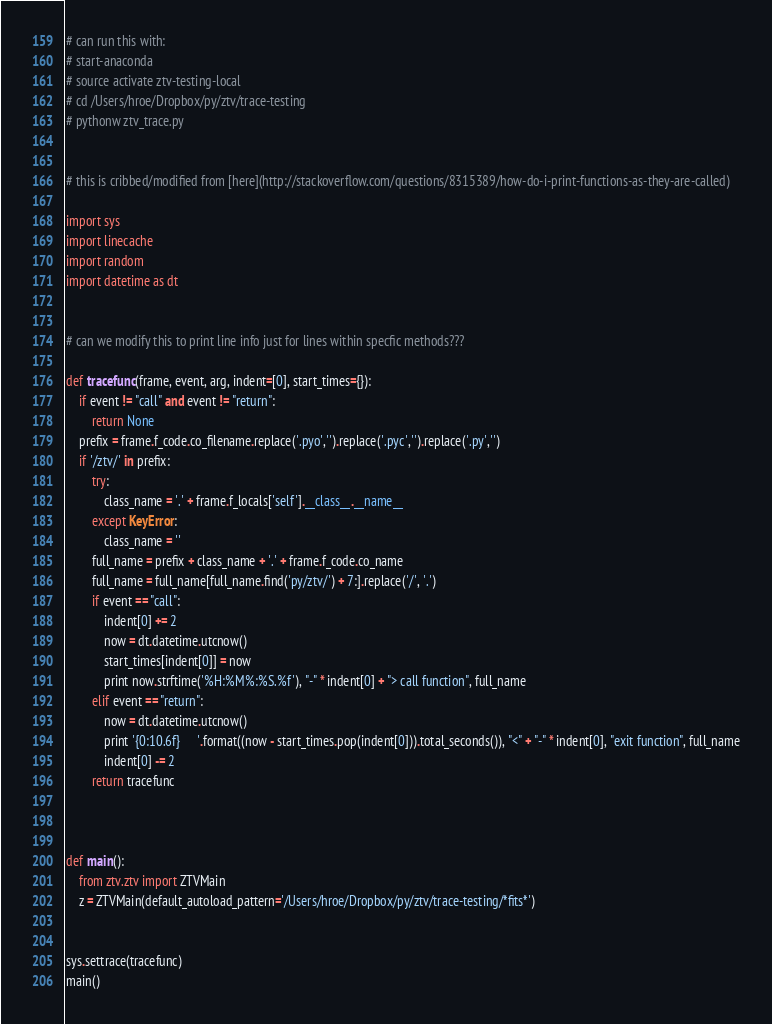Convert code to text. <code><loc_0><loc_0><loc_500><loc_500><_Python_>
# can run this with:
# start-anaconda
# source activate ztv-testing-local
# cd /Users/hroe/Dropbox/py/ztv/trace-testing
# pythonw ztv_trace.py


# this is cribbed/modified from [here](http://stackoverflow.com/questions/8315389/how-do-i-print-functions-as-they-are-called)

import sys
import linecache
import random
import datetime as dt


# can we modify this to print line info just for lines within specfic methods???

def tracefunc(frame, event, arg, indent=[0], start_times={}):
    if event != "call" and event != "return":
        return None
    prefix = frame.f_code.co_filename.replace('.pyo','').replace('.pyc','').replace('.py','')
    if '/ztv/' in prefix:
        try:
            class_name = '.' + frame.f_locals['self'].__class__.__name__
        except KeyError:
            class_name = ''
        full_name = prefix + class_name + '.' + frame.f_code.co_name 
        full_name = full_name[full_name.find('py/ztv/') + 7:].replace('/', '.')
        if event == "call":            
            indent[0] += 2
            now = dt.datetime.utcnow()
            start_times[indent[0]] = now
            print now.strftime('%H:%M%:%S.%f'), "-" * indent[0] + "> call function", full_name
        elif event == "return":
            now = dt.datetime.utcnow()
            print '{0:10.6f}     '.format((now - start_times.pop(indent[0])).total_seconds()), "<" + "-" * indent[0], "exit function", full_name
            indent[0] -= 2
        return tracefunc



def main():
    from ztv.ztv import ZTVMain
    z = ZTVMain(default_autoload_pattern='/Users/hroe/Dropbox/py/ztv/trace-testing/*fits*')
    
    
sys.settrace(tracefunc)
main()
</code> 